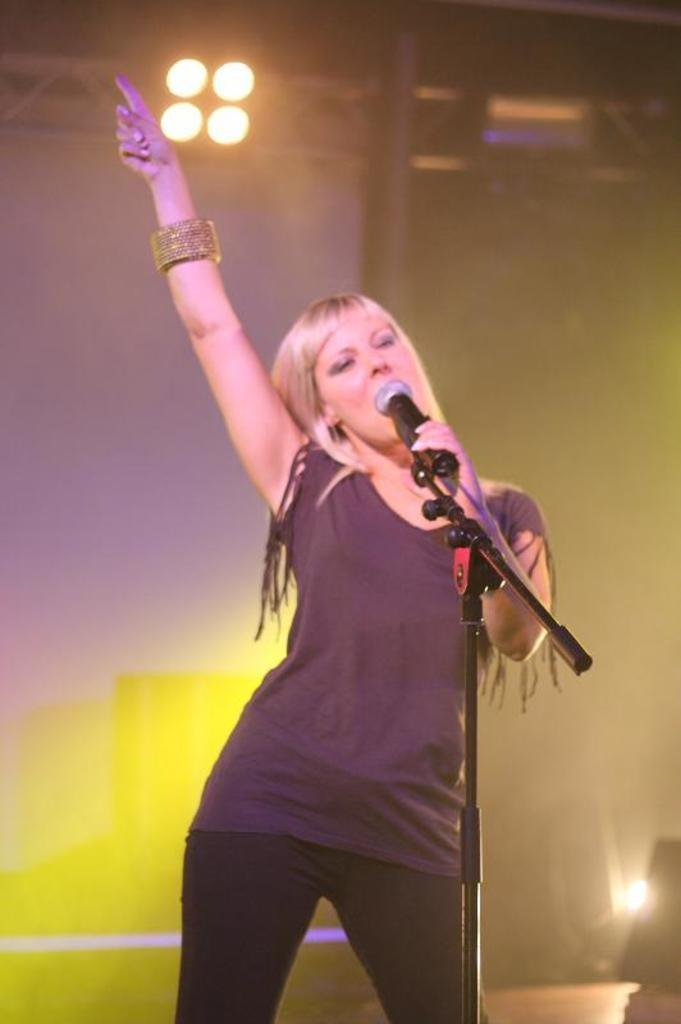Who is the main subject in the image? There is a girl in the image. What is the girl doing in the image? The girl is singing. What object is the girl holding in her hand? The girl is holding a microphone in one of her hands. What event is the image capturing? The image was taken at a musical concert. What type of birthday cake is on the stage during the concert? There is no mention of a birthday cake or any celebration in the image. The image is focused on the girl singing at a musical concert. 